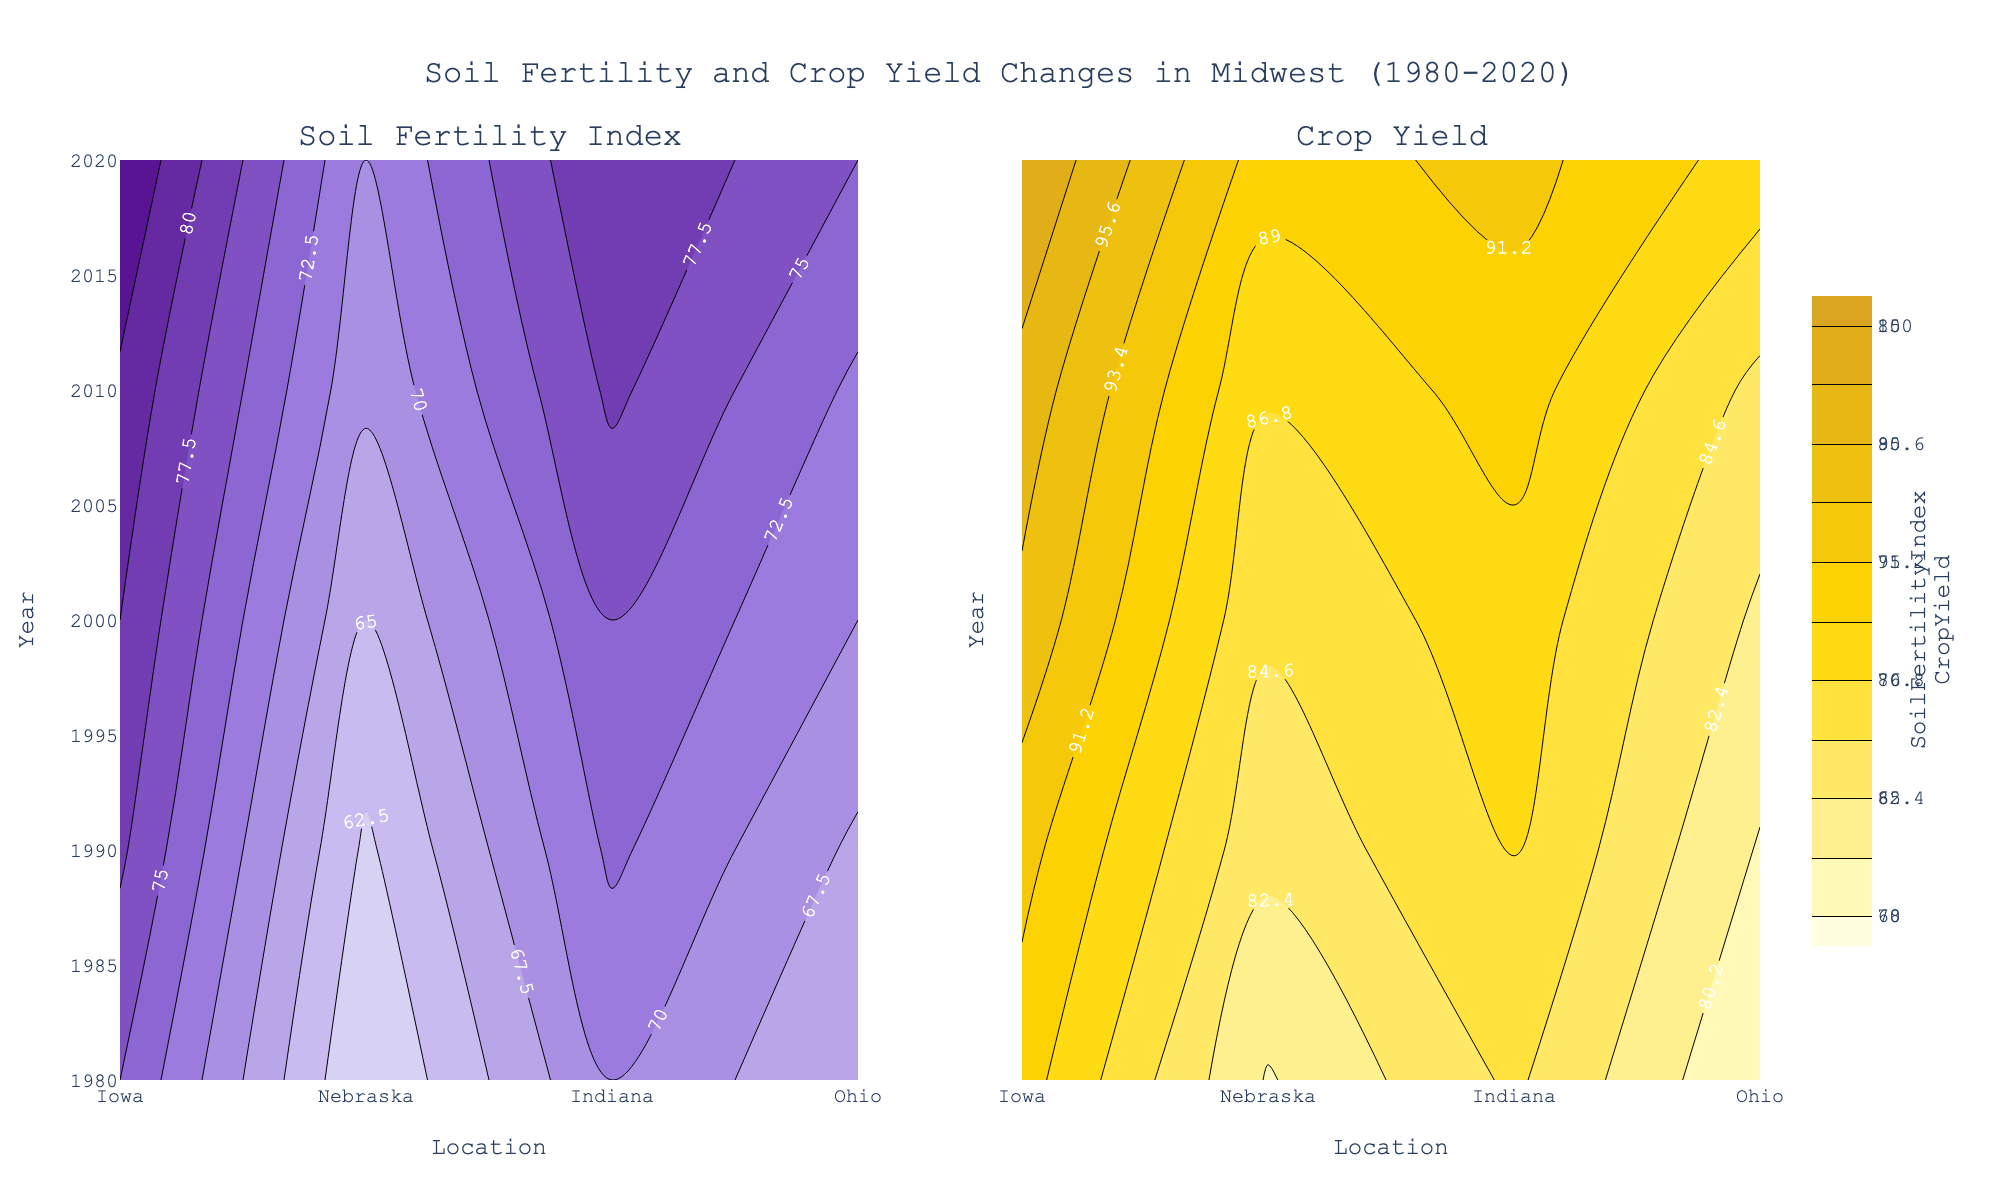What is the general trend in Soil Fertility Index for Iowa from 1980 to 2020? By examining the specific contour corresponding to Iowa in the Soil Fertility sublot, you can observe how the index increments across the years. Notice the gradual color transitions from lighter to darker shades, indicating increasing values.
Answer: It increases How does the Crop Yield for Nebraska in 2010 compare to the Crop Yield for Ohio in 2020? In the sublot for Crop Yield, locate the 2010 row for Nebraska and the 2020 row for Ohio. Evaluate the contour values for both points. Nebraska shows a Crop Yield around 87, while Ohio in 2020 shows a Crop Yield around 88.
Answer: Ohio 2020 has a slightly higher yield Between which two decades did the Soil Fertility Index for Indiana show the greatest increase? Observe the contour plot for Indiana in the Soil Fertility subplot. Compare the index values for each pair of consecutive decades. From 1980 to 1990, from 1990 to 2000, from 2000 to 2010, and from 2010 to 2020, note the differences. The most significant increase is from 2000 to 2010 when the index moved from 75 to 78.
Answer: 2000 to 2010 What is the difference in Soil Fertility Index between Ohio and Indiana in 1990? Locate the values for both Ohio and Indiana in the year 1990 within the Soil Fertility subplot. Subtract the value for Ohio (67) from the value for Indiana (73) to find the difference.
Answer: 6 In which location and year was the highest Crop Yield observed? Identify the darkest shade in the Crop Yield subplot, indicating the highest value. Iowa in 2020 appears darkest, pointing to the highest observed yield.
Answer: Iowa in 2020 Compare the trend of Soil Fertility Index for Ohio to that of Nebraska between 1980 and 2020. Follow the contour lines corresponding to Ohio and Nebraska in the Soil Fertility subplot. Notice that both indices increase over time, but Ohio seems to show a steeper increase compared to Nebraska, especially noticeable after 2000.
Answer: Both increase, Ohio increases more What is the average Soil Fertility Index value in 2000 across all locations? Collect the values from the Soil Fertility subplot for the year 2000 across Iowa (80), Nebraska (65), Indiana (75), and Ohio (70). Sum these values (80 + 65 + 75 + 70 = 290) and divide by the number of locations (4), yielding the average.
Answer: 72.5 Which location shows the least variability in Crop Yield from 1980 to 2020? Examine the Crop Yield contours for all years in each location. The smoother and more consistent the color transition indicates less variability. Nebraska shows less fluctuation in color shades compared to others.
Answer: Nebraska 